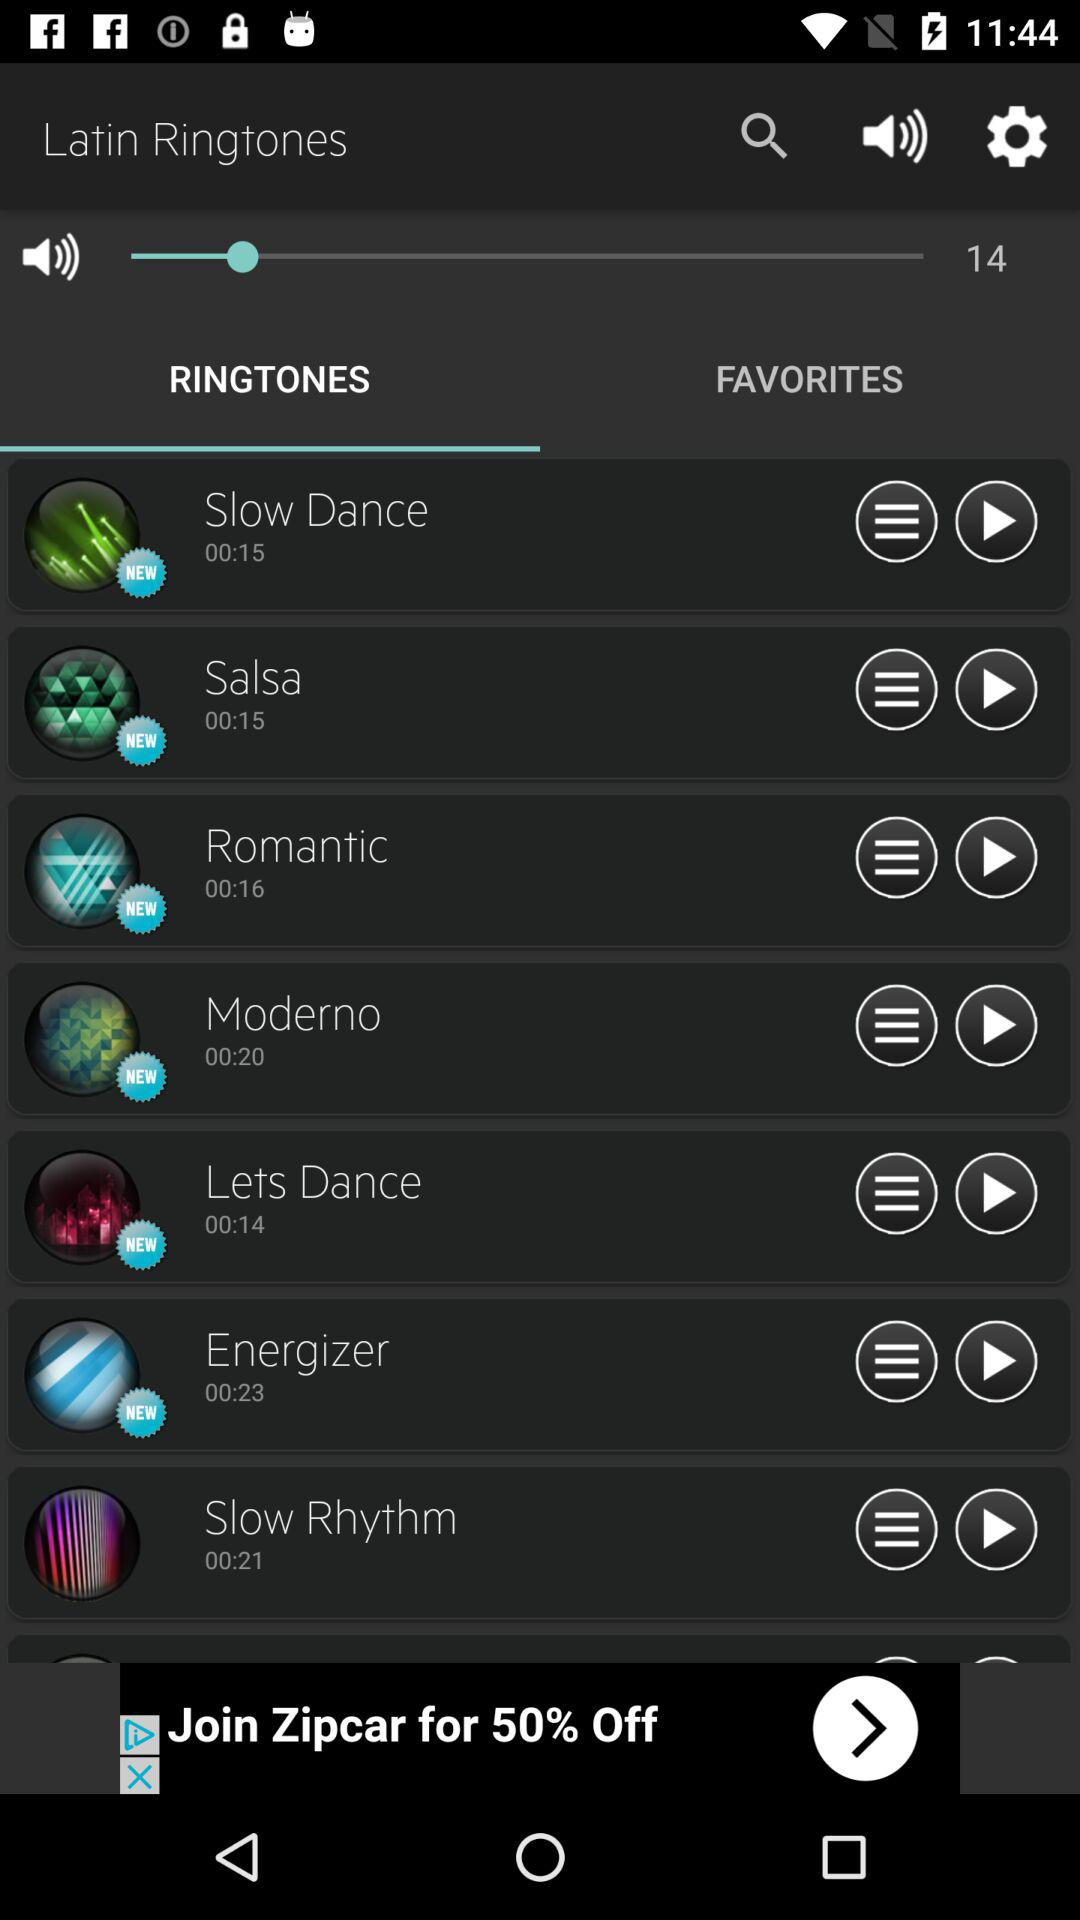What is the volume of the ringtone? The volume is 14. 